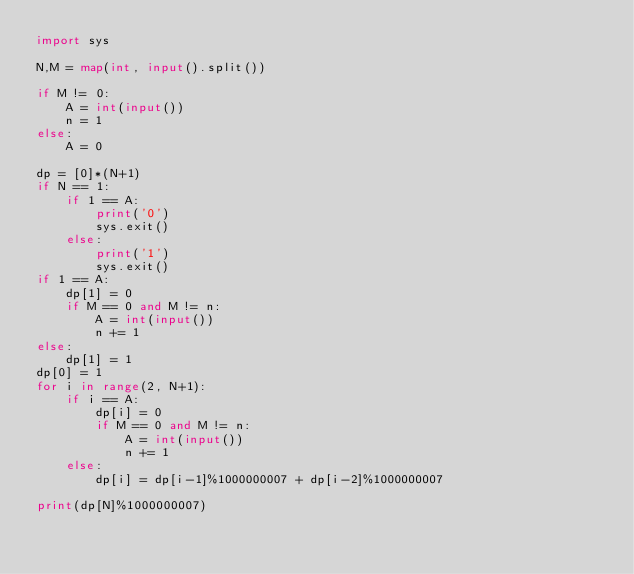Convert code to text. <code><loc_0><loc_0><loc_500><loc_500><_Python_>import sys

N,M = map(int, input().split())

if M != 0:
    A = int(input())
    n = 1
else:
    A = 0

dp = [0]*(N+1)
if N == 1:
    if 1 == A:
        print('0')
        sys.exit()
    else:
        print('1')
        sys.exit()
if 1 == A:
    dp[1] = 0
    if M == 0 and M != n:
        A = int(input())
        n += 1
else:
    dp[1] = 1
dp[0] = 1
for i in range(2, N+1):
    if i == A:
        dp[i] = 0
        if M == 0 and M != n:
            A = int(input())
            n += 1
    else:
        dp[i] = dp[i-1]%1000000007 + dp[i-2]%1000000007

print(dp[N]%1000000007)</code> 